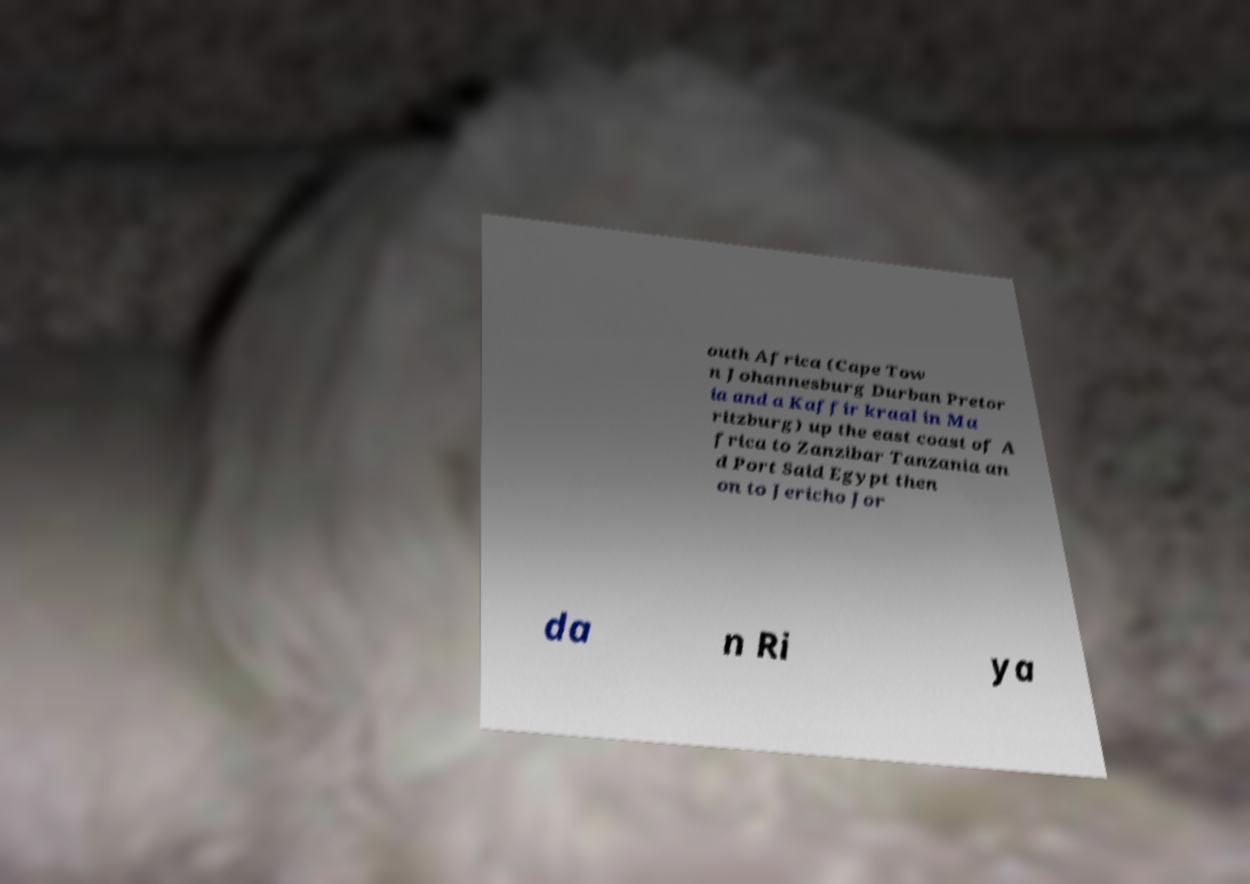Can you read and provide the text displayed in the image?This photo seems to have some interesting text. Can you extract and type it out for me? outh Africa (Cape Tow n Johannesburg Durban Pretor ia and a Kaffir kraal in Ma ritzburg) up the east coast of A frica to Zanzibar Tanzania an d Port Said Egypt then on to Jericho Jor da n Ri ya 